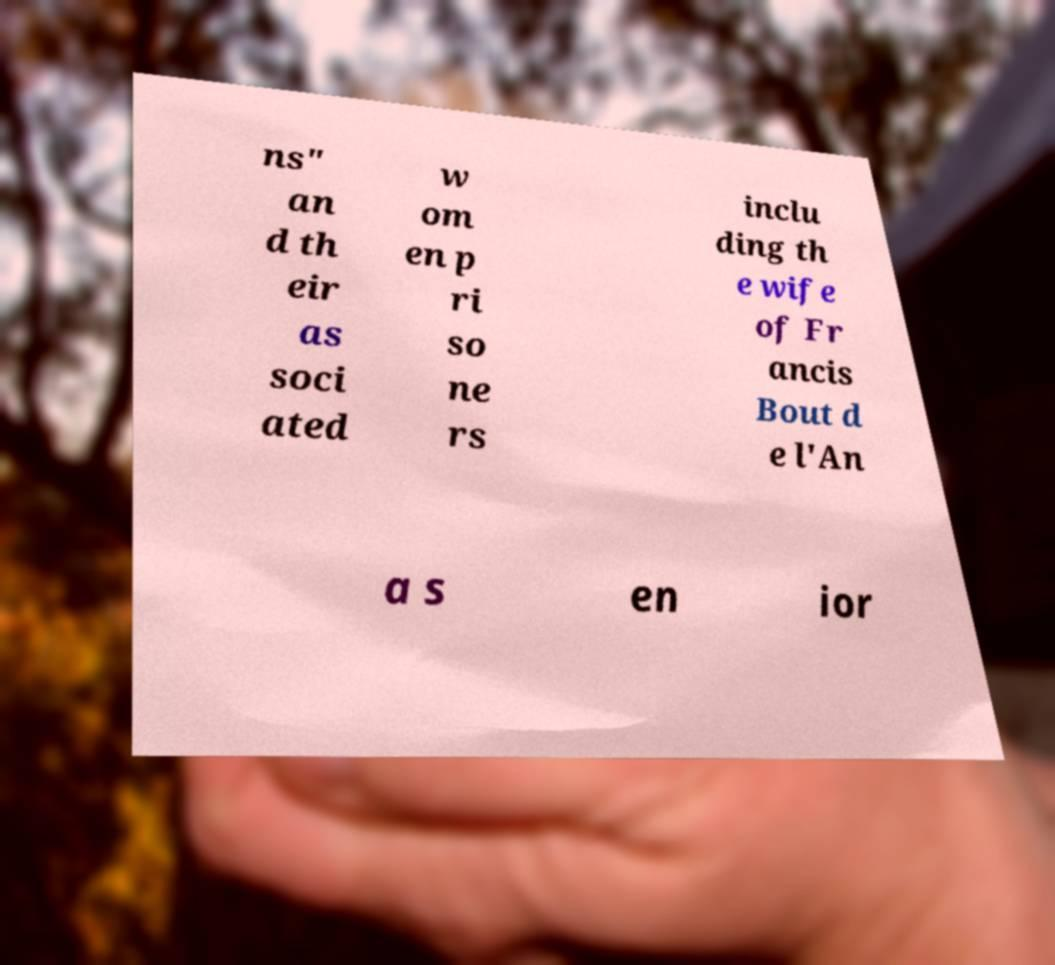Could you assist in decoding the text presented in this image and type it out clearly? ns" an d th eir as soci ated w om en p ri so ne rs inclu ding th e wife of Fr ancis Bout d e l'An a s en ior 